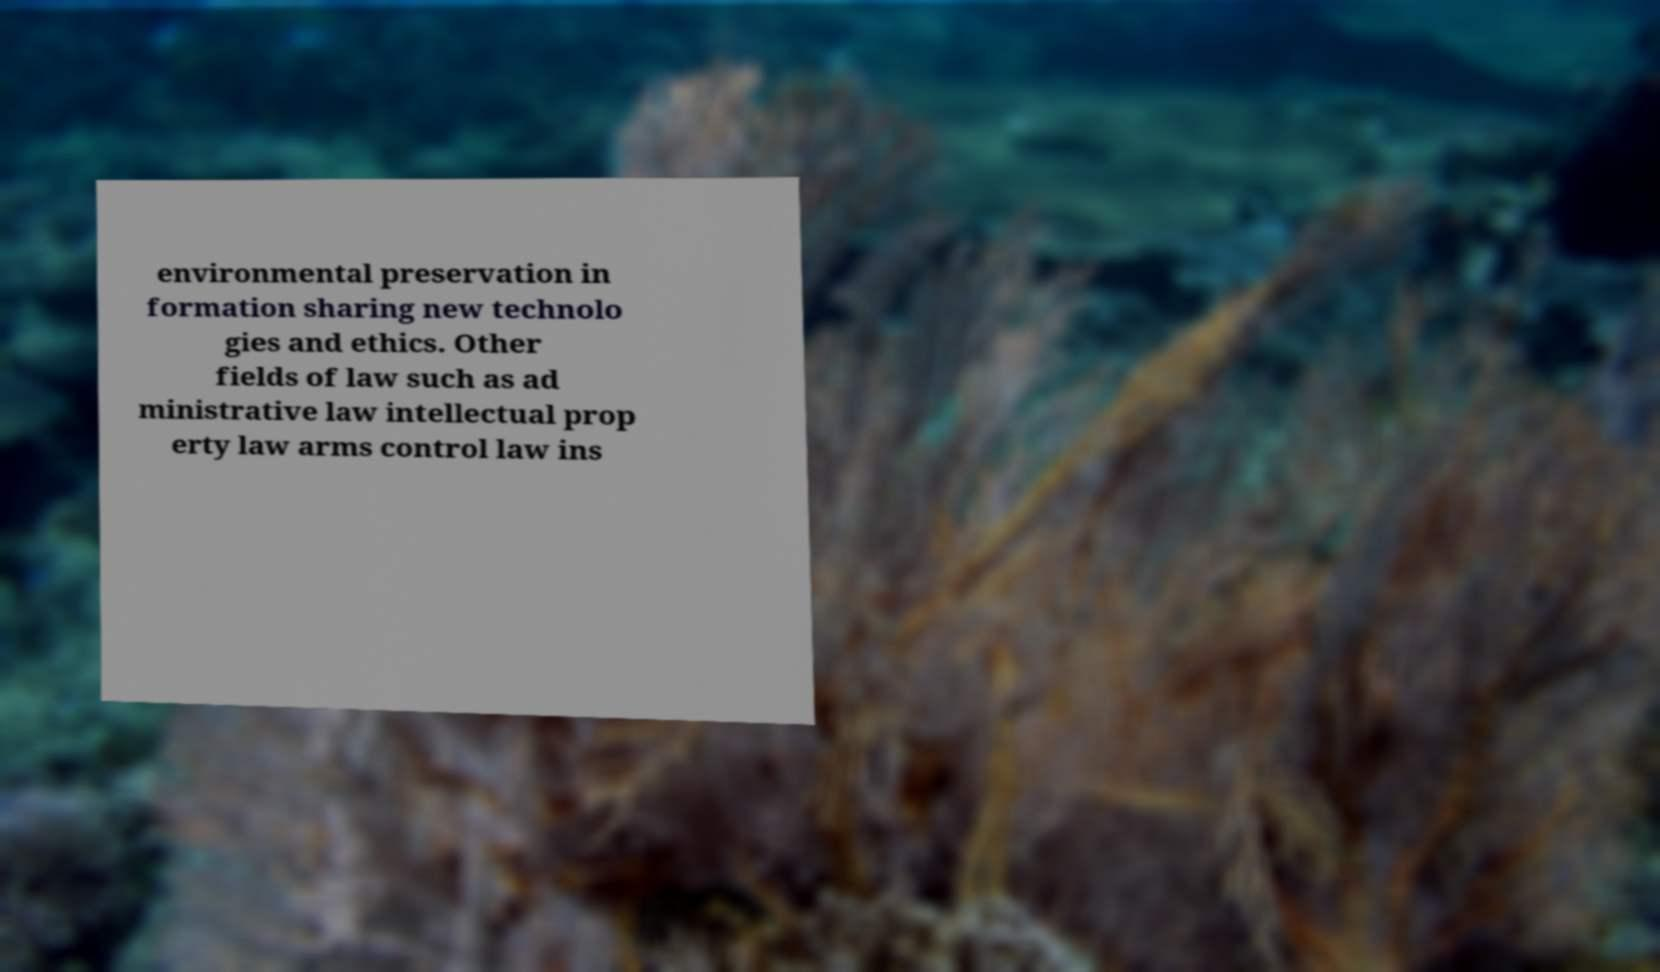Could you extract and type out the text from this image? environmental preservation in formation sharing new technolo gies and ethics. Other fields of law such as ad ministrative law intellectual prop erty law arms control law ins 